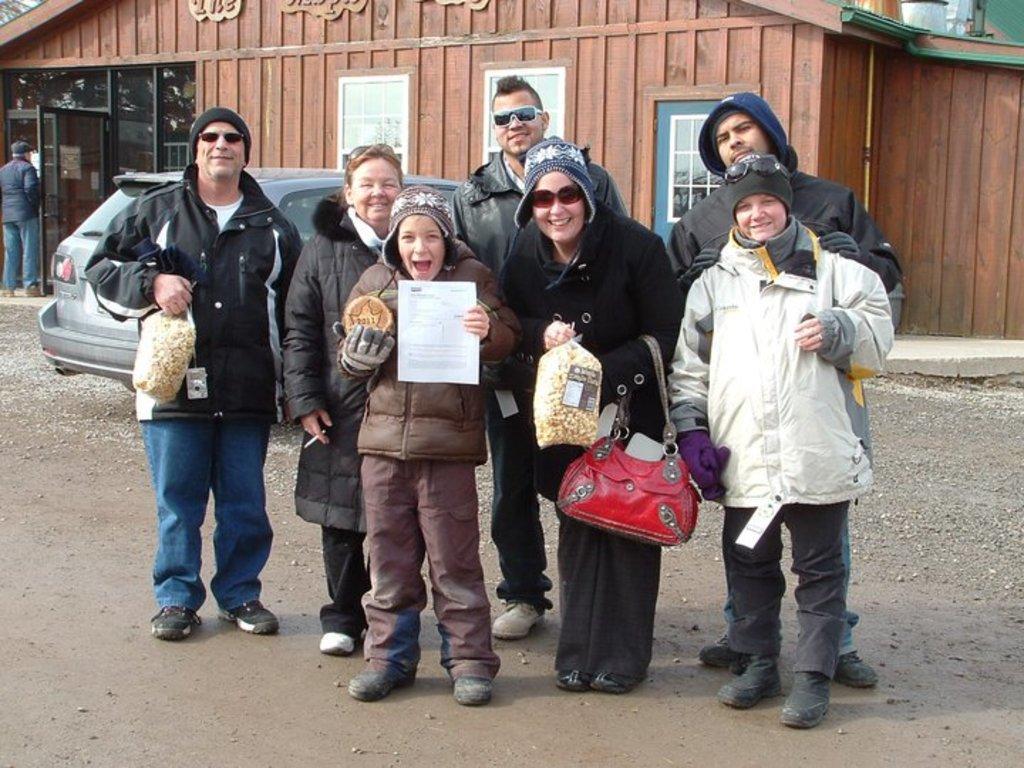Please provide a concise description of this image. As we can see in the image there is a house, window, car and few people over here. 